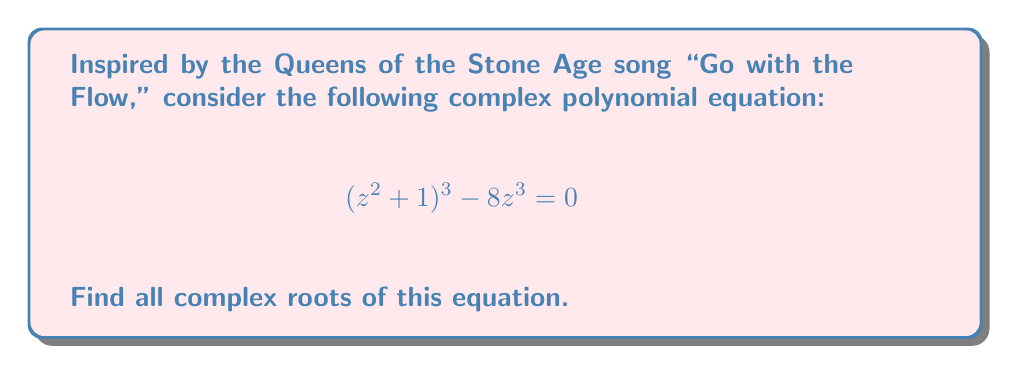What is the answer to this math problem? Let's approach this step-by-step:

1) First, let's rearrange the equation:
   $$(z^2 + 1)^3 = 8z^3$$

2) Let's substitute $w = z^2 + 1$. This gives us:
   $$w^3 = 8(w-1)^{3/2}$$

3) Cubing both sides:
   $$w^9 = 512(w-1)^3$$

4) Expanding the right side:
   $$w^9 = 512w^3 - 1536w^2 + 1536w - 512$$

5) Rearranging:
   $$w^9 - 512w^3 + 1536w^2 - 1536w + 512 = 0$$

6) This is a 9th degree polynomial in $w$. It can be factored as:
   $$(w-1)^3(w^2+w+1)^3 = 0$$

7) Solving $w-1 = 0$ and $w^2+w+1 = 0$, we get:
   $$w = 1$$ or $$w = \frac{-1 \pm i\sqrt{3}}{2}$$

8) Recall that $w = z^2 + 1$. So we need to solve:
   $$z^2 = 0$$ and $$z^2 = \frac{-3 \pm i\sqrt{3}}{2}$$

9) From $z^2 = 0$, we get $z = 0$ (double root).

10) From $z^2 = \frac{-3 + i\sqrt{3}}{2}$, we get:
    $$z = \pm (\frac{\sqrt{3}}{2} + \frac{i}{2})$$

11) From $z^2 = \frac{-3 - i\sqrt{3}}{2}$, we get:
    $$z = \pm (\frac{\sqrt{3}}{2} - \frac{i}{2})$$
Answer: $z = 0$ (double root), $\pm (\frac{\sqrt{3}}{2} + \frac{i}{2})$, $\pm (\frac{\sqrt{3}}{2} - \frac{i}{2})$ 